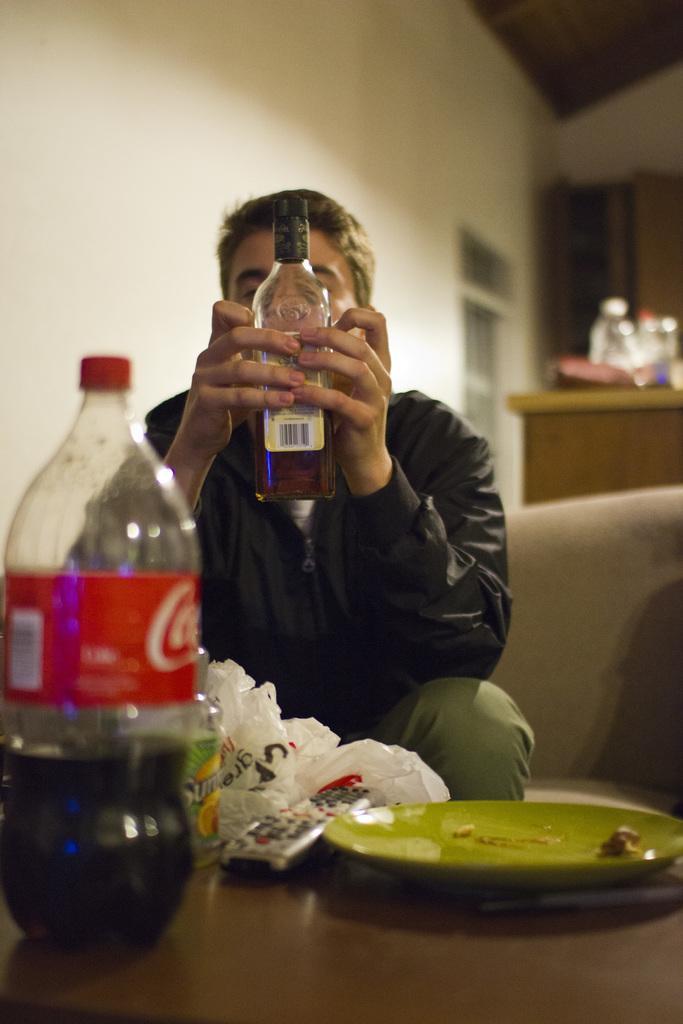In one or two sentences, can you explain what this image depicts? In this image I can see a man is holding a bottle. Here I can see one more bottle, a remote and a plate. 